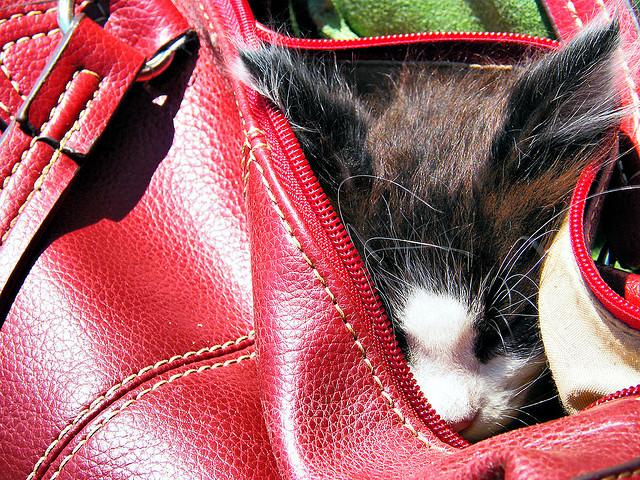What color is the bag?
Short answer required. Red. Why is the kitty hiding?
Concise answer only. Sleeping. Is this a normal cat carrier?
Be succinct. No. 